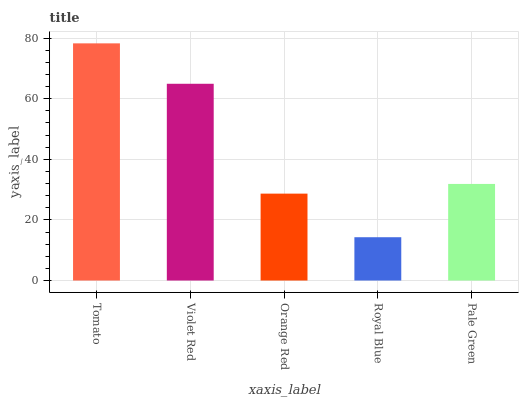Is Royal Blue the minimum?
Answer yes or no. Yes. Is Tomato the maximum?
Answer yes or no. Yes. Is Violet Red the minimum?
Answer yes or no. No. Is Violet Red the maximum?
Answer yes or no. No. Is Tomato greater than Violet Red?
Answer yes or no. Yes. Is Violet Red less than Tomato?
Answer yes or no. Yes. Is Violet Red greater than Tomato?
Answer yes or no. No. Is Tomato less than Violet Red?
Answer yes or no. No. Is Pale Green the high median?
Answer yes or no. Yes. Is Pale Green the low median?
Answer yes or no. Yes. Is Orange Red the high median?
Answer yes or no. No. Is Orange Red the low median?
Answer yes or no. No. 